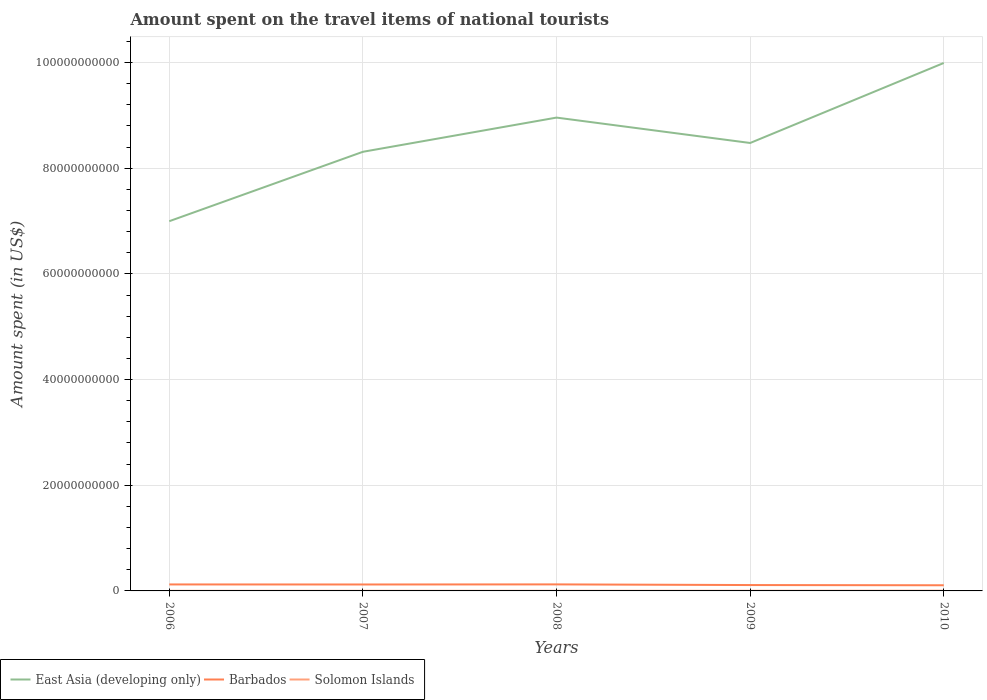Does the line corresponding to Solomon Islands intersect with the line corresponding to Barbados?
Offer a very short reply. No. Is the number of lines equal to the number of legend labels?
Provide a short and direct response. Yes. Across all years, what is the maximum amount spent on the travel items of national tourists in East Asia (developing only)?
Make the answer very short. 7.00e+1. What is the total amount spent on the travel items of national tourists in East Asia (developing only) in the graph?
Provide a succinct answer. -2.99e+1. What is the difference between the highest and the second highest amount spent on the travel items of national tourists in East Asia (developing only)?
Offer a very short reply. 2.99e+1. What is the difference between the highest and the lowest amount spent on the travel items of national tourists in Solomon Islands?
Ensure brevity in your answer.  2. Are the values on the major ticks of Y-axis written in scientific E-notation?
Provide a succinct answer. No. Does the graph contain grids?
Ensure brevity in your answer.  Yes. What is the title of the graph?
Your answer should be compact. Amount spent on the travel items of national tourists. Does "Dominica" appear as one of the legend labels in the graph?
Your response must be concise. No. What is the label or title of the X-axis?
Provide a short and direct response. Years. What is the label or title of the Y-axis?
Your answer should be compact. Amount spent (in US$). What is the Amount spent (in US$) in East Asia (developing only) in 2006?
Ensure brevity in your answer.  7.00e+1. What is the Amount spent (in US$) of Barbados in 2006?
Your response must be concise. 1.23e+09. What is the Amount spent (in US$) in Solomon Islands in 2006?
Give a very brief answer. 2.11e+07. What is the Amount spent (in US$) of East Asia (developing only) in 2007?
Give a very brief answer. 8.31e+1. What is the Amount spent (in US$) of Barbados in 2007?
Make the answer very short. 1.22e+09. What is the Amount spent (in US$) of Solomon Islands in 2007?
Make the answer very short. 2.26e+07. What is the Amount spent (in US$) in East Asia (developing only) in 2008?
Give a very brief answer. 8.96e+1. What is the Amount spent (in US$) in Barbados in 2008?
Offer a terse response. 1.24e+09. What is the Amount spent (in US$) of Solomon Islands in 2008?
Give a very brief answer. 2.75e+07. What is the Amount spent (in US$) of East Asia (developing only) in 2009?
Offer a very short reply. 8.48e+1. What is the Amount spent (in US$) of Barbados in 2009?
Provide a succinct answer. 1.11e+09. What is the Amount spent (in US$) of Solomon Islands in 2009?
Keep it short and to the point. 3.34e+07. What is the Amount spent (in US$) in East Asia (developing only) in 2010?
Offer a very short reply. 9.99e+1. What is the Amount spent (in US$) of Barbados in 2010?
Give a very brief answer. 1.07e+09. What is the Amount spent (in US$) in Solomon Islands in 2010?
Provide a short and direct response. 4.35e+07. Across all years, what is the maximum Amount spent (in US$) of East Asia (developing only)?
Your response must be concise. 9.99e+1. Across all years, what is the maximum Amount spent (in US$) of Barbados?
Ensure brevity in your answer.  1.24e+09. Across all years, what is the maximum Amount spent (in US$) of Solomon Islands?
Offer a very short reply. 4.35e+07. Across all years, what is the minimum Amount spent (in US$) of East Asia (developing only)?
Offer a very short reply. 7.00e+1. Across all years, what is the minimum Amount spent (in US$) in Barbados?
Your answer should be compact. 1.07e+09. Across all years, what is the minimum Amount spent (in US$) in Solomon Islands?
Your answer should be very brief. 2.11e+07. What is the total Amount spent (in US$) of East Asia (developing only) in the graph?
Keep it short and to the point. 4.27e+11. What is the total Amount spent (in US$) in Barbados in the graph?
Keep it short and to the point. 5.86e+09. What is the total Amount spent (in US$) of Solomon Islands in the graph?
Keep it short and to the point. 1.48e+08. What is the difference between the Amount spent (in US$) in East Asia (developing only) in 2006 and that in 2007?
Offer a terse response. -1.31e+1. What is the difference between the Amount spent (in US$) of Barbados in 2006 and that in 2007?
Your response must be concise. 1.10e+07. What is the difference between the Amount spent (in US$) of Solomon Islands in 2006 and that in 2007?
Offer a terse response. -1.50e+06. What is the difference between the Amount spent (in US$) of East Asia (developing only) in 2006 and that in 2008?
Give a very brief answer. -1.96e+1. What is the difference between the Amount spent (in US$) in Barbados in 2006 and that in 2008?
Ensure brevity in your answer.  -9.00e+06. What is the difference between the Amount spent (in US$) of Solomon Islands in 2006 and that in 2008?
Keep it short and to the point. -6.40e+06. What is the difference between the Amount spent (in US$) in East Asia (developing only) in 2006 and that in 2009?
Offer a very short reply. -1.48e+1. What is the difference between the Amount spent (in US$) in Barbados in 2006 and that in 2009?
Provide a short and direct response. 1.16e+08. What is the difference between the Amount spent (in US$) in Solomon Islands in 2006 and that in 2009?
Provide a succinct answer. -1.23e+07. What is the difference between the Amount spent (in US$) in East Asia (developing only) in 2006 and that in 2010?
Provide a short and direct response. -2.99e+1. What is the difference between the Amount spent (in US$) of Barbados in 2006 and that in 2010?
Offer a very short reply. 1.57e+08. What is the difference between the Amount spent (in US$) in Solomon Islands in 2006 and that in 2010?
Keep it short and to the point. -2.24e+07. What is the difference between the Amount spent (in US$) of East Asia (developing only) in 2007 and that in 2008?
Keep it short and to the point. -6.47e+09. What is the difference between the Amount spent (in US$) of Barbados in 2007 and that in 2008?
Give a very brief answer. -2.00e+07. What is the difference between the Amount spent (in US$) of Solomon Islands in 2007 and that in 2008?
Provide a succinct answer. -4.90e+06. What is the difference between the Amount spent (in US$) in East Asia (developing only) in 2007 and that in 2009?
Make the answer very short. -1.67e+09. What is the difference between the Amount spent (in US$) of Barbados in 2007 and that in 2009?
Your response must be concise. 1.05e+08. What is the difference between the Amount spent (in US$) of Solomon Islands in 2007 and that in 2009?
Make the answer very short. -1.08e+07. What is the difference between the Amount spent (in US$) in East Asia (developing only) in 2007 and that in 2010?
Provide a short and direct response. -1.68e+1. What is the difference between the Amount spent (in US$) in Barbados in 2007 and that in 2010?
Make the answer very short. 1.46e+08. What is the difference between the Amount spent (in US$) of Solomon Islands in 2007 and that in 2010?
Your answer should be very brief. -2.09e+07. What is the difference between the Amount spent (in US$) in East Asia (developing only) in 2008 and that in 2009?
Offer a very short reply. 4.81e+09. What is the difference between the Amount spent (in US$) in Barbados in 2008 and that in 2009?
Offer a terse response. 1.25e+08. What is the difference between the Amount spent (in US$) of Solomon Islands in 2008 and that in 2009?
Offer a terse response. -5.90e+06. What is the difference between the Amount spent (in US$) of East Asia (developing only) in 2008 and that in 2010?
Provide a short and direct response. -1.03e+1. What is the difference between the Amount spent (in US$) in Barbados in 2008 and that in 2010?
Your response must be concise. 1.66e+08. What is the difference between the Amount spent (in US$) in Solomon Islands in 2008 and that in 2010?
Your answer should be compact. -1.60e+07. What is the difference between the Amount spent (in US$) in East Asia (developing only) in 2009 and that in 2010?
Ensure brevity in your answer.  -1.51e+1. What is the difference between the Amount spent (in US$) of Barbados in 2009 and that in 2010?
Offer a very short reply. 4.10e+07. What is the difference between the Amount spent (in US$) in Solomon Islands in 2009 and that in 2010?
Give a very brief answer. -1.01e+07. What is the difference between the Amount spent (in US$) in East Asia (developing only) in 2006 and the Amount spent (in US$) in Barbados in 2007?
Keep it short and to the point. 6.88e+1. What is the difference between the Amount spent (in US$) of East Asia (developing only) in 2006 and the Amount spent (in US$) of Solomon Islands in 2007?
Offer a very short reply. 7.00e+1. What is the difference between the Amount spent (in US$) of Barbados in 2006 and the Amount spent (in US$) of Solomon Islands in 2007?
Your answer should be compact. 1.21e+09. What is the difference between the Amount spent (in US$) of East Asia (developing only) in 2006 and the Amount spent (in US$) of Barbados in 2008?
Provide a short and direct response. 6.87e+1. What is the difference between the Amount spent (in US$) in East Asia (developing only) in 2006 and the Amount spent (in US$) in Solomon Islands in 2008?
Your response must be concise. 6.99e+1. What is the difference between the Amount spent (in US$) in Barbados in 2006 and the Amount spent (in US$) in Solomon Islands in 2008?
Keep it short and to the point. 1.20e+09. What is the difference between the Amount spent (in US$) of East Asia (developing only) in 2006 and the Amount spent (in US$) of Barbados in 2009?
Offer a terse response. 6.89e+1. What is the difference between the Amount spent (in US$) of East Asia (developing only) in 2006 and the Amount spent (in US$) of Solomon Islands in 2009?
Provide a succinct answer. 6.99e+1. What is the difference between the Amount spent (in US$) of Barbados in 2006 and the Amount spent (in US$) of Solomon Islands in 2009?
Provide a short and direct response. 1.19e+09. What is the difference between the Amount spent (in US$) in East Asia (developing only) in 2006 and the Amount spent (in US$) in Barbados in 2010?
Your answer should be very brief. 6.89e+1. What is the difference between the Amount spent (in US$) of East Asia (developing only) in 2006 and the Amount spent (in US$) of Solomon Islands in 2010?
Offer a terse response. 6.99e+1. What is the difference between the Amount spent (in US$) of Barbados in 2006 and the Amount spent (in US$) of Solomon Islands in 2010?
Provide a short and direct response. 1.18e+09. What is the difference between the Amount spent (in US$) of East Asia (developing only) in 2007 and the Amount spent (in US$) of Barbados in 2008?
Make the answer very short. 8.19e+1. What is the difference between the Amount spent (in US$) in East Asia (developing only) in 2007 and the Amount spent (in US$) in Solomon Islands in 2008?
Make the answer very short. 8.31e+1. What is the difference between the Amount spent (in US$) of Barbados in 2007 and the Amount spent (in US$) of Solomon Islands in 2008?
Give a very brief answer. 1.19e+09. What is the difference between the Amount spent (in US$) of East Asia (developing only) in 2007 and the Amount spent (in US$) of Barbados in 2009?
Offer a terse response. 8.20e+1. What is the difference between the Amount spent (in US$) of East Asia (developing only) in 2007 and the Amount spent (in US$) of Solomon Islands in 2009?
Offer a terse response. 8.31e+1. What is the difference between the Amount spent (in US$) in Barbados in 2007 and the Amount spent (in US$) in Solomon Islands in 2009?
Offer a very short reply. 1.18e+09. What is the difference between the Amount spent (in US$) of East Asia (developing only) in 2007 and the Amount spent (in US$) of Barbados in 2010?
Ensure brevity in your answer.  8.20e+1. What is the difference between the Amount spent (in US$) of East Asia (developing only) in 2007 and the Amount spent (in US$) of Solomon Islands in 2010?
Your response must be concise. 8.31e+1. What is the difference between the Amount spent (in US$) of Barbados in 2007 and the Amount spent (in US$) of Solomon Islands in 2010?
Provide a succinct answer. 1.17e+09. What is the difference between the Amount spent (in US$) of East Asia (developing only) in 2008 and the Amount spent (in US$) of Barbados in 2009?
Give a very brief answer. 8.85e+1. What is the difference between the Amount spent (in US$) of East Asia (developing only) in 2008 and the Amount spent (in US$) of Solomon Islands in 2009?
Keep it short and to the point. 8.96e+1. What is the difference between the Amount spent (in US$) in Barbados in 2008 and the Amount spent (in US$) in Solomon Islands in 2009?
Your answer should be very brief. 1.20e+09. What is the difference between the Amount spent (in US$) of East Asia (developing only) in 2008 and the Amount spent (in US$) of Barbados in 2010?
Ensure brevity in your answer.  8.85e+1. What is the difference between the Amount spent (in US$) in East Asia (developing only) in 2008 and the Amount spent (in US$) in Solomon Islands in 2010?
Your answer should be compact. 8.95e+1. What is the difference between the Amount spent (in US$) of Barbados in 2008 and the Amount spent (in US$) of Solomon Islands in 2010?
Your answer should be very brief. 1.19e+09. What is the difference between the Amount spent (in US$) in East Asia (developing only) in 2009 and the Amount spent (in US$) in Barbados in 2010?
Make the answer very short. 8.37e+1. What is the difference between the Amount spent (in US$) in East Asia (developing only) in 2009 and the Amount spent (in US$) in Solomon Islands in 2010?
Your response must be concise. 8.47e+1. What is the difference between the Amount spent (in US$) in Barbados in 2009 and the Amount spent (in US$) in Solomon Islands in 2010?
Your answer should be very brief. 1.07e+09. What is the average Amount spent (in US$) in East Asia (developing only) per year?
Your answer should be compact. 8.55e+1. What is the average Amount spent (in US$) in Barbados per year?
Make the answer very short. 1.17e+09. What is the average Amount spent (in US$) in Solomon Islands per year?
Offer a very short reply. 2.96e+07. In the year 2006, what is the difference between the Amount spent (in US$) of East Asia (developing only) and Amount spent (in US$) of Barbados?
Ensure brevity in your answer.  6.87e+1. In the year 2006, what is the difference between the Amount spent (in US$) in East Asia (developing only) and Amount spent (in US$) in Solomon Islands?
Offer a very short reply. 7.00e+1. In the year 2006, what is the difference between the Amount spent (in US$) of Barbados and Amount spent (in US$) of Solomon Islands?
Offer a terse response. 1.21e+09. In the year 2007, what is the difference between the Amount spent (in US$) of East Asia (developing only) and Amount spent (in US$) of Barbados?
Give a very brief answer. 8.19e+1. In the year 2007, what is the difference between the Amount spent (in US$) of East Asia (developing only) and Amount spent (in US$) of Solomon Islands?
Give a very brief answer. 8.31e+1. In the year 2007, what is the difference between the Amount spent (in US$) of Barbados and Amount spent (in US$) of Solomon Islands?
Ensure brevity in your answer.  1.19e+09. In the year 2008, what is the difference between the Amount spent (in US$) of East Asia (developing only) and Amount spent (in US$) of Barbados?
Make the answer very short. 8.83e+1. In the year 2008, what is the difference between the Amount spent (in US$) of East Asia (developing only) and Amount spent (in US$) of Solomon Islands?
Keep it short and to the point. 8.96e+1. In the year 2008, what is the difference between the Amount spent (in US$) of Barbados and Amount spent (in US$) of Solomon Islands?
Give a very brief answer. 1.21e+09. In the year 2009, what is the difference between the Amount spent (in US$) of East Asia (developing only) and Amount spent (in US$) of Barbados?
Your answer should be very brief. 8.37e+1. In the year 2009, what is the difference between the Amount spent (in US$) in East Asia (developing only) and Amount spent (in US$) in Solomon Islands?
Ensure brevity in your answer.  8.47e+1. In the year 2009, what is the difference between the Amount spent (in US$) of Barbados and Amount spent (in US$) of Solomon Islands?
Offer a very short reply. 1.08e+09. In the year 2010, what is the difference between the Amount spent (in US$) of East Asia (developing only) and Amount spent (in US$) of Barbados?
Provide a short and direct response. 9.89e+1. In the year 2010, what is the difference between the Amount spent (in US$) of East Asia (developing only) and Amount spent (in US$) of Solomon Islands?
Make the answer very short. 9.99e+1. In the year 2010, what is the difference between the Amount spent (in US$) of Barbados and Amount spent (in US$) of Solomon Islands?
Your answer should be very brief. 1.03e+09. What is the ratio of the Amount spent (in US$) in East Asia (developing only) in 2006 to that in 2007?
Provide a short and direct response. 0.84. What is the ratio of the Amount spent (in US$) in Barbados in 2006 to that in 2007?
Give a very brief answer. 1.01. What is the ratio of the Amount spent (in US$) of Solomon Islands in 2006 to that in 2007?
Your response must be concise. 0.93. What is the ratio of the Amount spent (in US$) in East Asia (developing only) in 2006 to that in 2008?
Offer a very short reply. 0.78. What is the ratio of the Amount spent (in US$) in Solomon Islands in 2006 to that in 2008?
Make the answer very short. 0.77. What is the ratio of the Amount spent (in US$) in East Asia (developing only) in 2006 to that in 2009?
Your answer should be compact. 0.83. What is the ratio of the Amount spent (in US$) in Barbados in 2006 to that in 2009?
Provide a short and direct response. 1.1. What is the ratio of the Amount spent (in US$) of Solomon Islands in 2006 to that in 2009?
Your response must be concise. 0.63. What is the ratio of the Amount spent (in US$) in East Asia (developing only) in 2006 to that in 2010?
Provide a succinct answer. 0.7. What is the ratio of the Amount spent (in US$) of Barbados in 2006 to that in 2010?
Offer a very short reply. 1.15. What is the ratio of the Amount spent (in US$) of Solomon Islands in 2006 to that in 2010?
Offer a terse response. 0.49. What is the ratio of the Amount spent (in US$) in East Asia (developing only) in 2007 to that in 2008?
Your response must be concise. 0.93. What is the ratio of the Amount spent (in US$) of Barbados in 2007 to that in 2008?
Make the answer very short. 0.98. What is the ratio of the Amount spent (in US$) of Solomon Islands in 2007 to that in 2008?
Keep it short and to the point. 0.82. What is the ratio of the Amount spent (in US$) of East Asia (developing only) in 2007 to that in 2009?
Offer a very short reply. 0.98. What is the ratio of the Amount spent (in US$) of Barbados in 2007 to that in 2009?
Give a very brief answer. 1.09. What is the ratio of the Amount spent (in US$) in Solomon Islands in 2007 to that in 2009?
Ensure brevity in your answer.  0.68. What is the ratio of the Amount spent (in US$) in East Asia (developing only) in 2007 to that in 2010?
Ensure brevity in your answer.  0.83. What is the ratio of the Amount spent (in US$) in Barbados in 2007 to that in 2010?
Keep it short and to the point. 1.14. What is the ratio of the Amount spent (in US$) of Solomon Islands in 2007 to that in 2010?
Ensure brevity in your answer.  0.52. What is the ratio of the Amount spent (in US$) in East Asia (developing only) in 2008 to that in 2009?
Your answer should be very brief. 1.06. What is the ratio of the Amount spent (in US$) of Barbados in 2008 to that in 2009?
Offer a very short reply. 1.11. What is the ratio of the Amount spent (in US$) in Solomon Islands in 2008 to that in 2009?
Give a very brief answer. 0.82. What is the ratio of the Amount spent (in US$) of East Asia (developing only) in 2008 to that in 2010?
Provide a short and direct response. 0.9. What is the ratio of the Amount spent (in US$) of Barbados in 2008 to that in 2010?
Make the answer very short. 1.16. What is the ratio of the Amount spent (in US$) of Solomon Islands in 2008 to that in 2010?
Provide a succinct answer. 0.63. What is the ratio of the Amount spent (in US$) in East Asia (developing only) in 2009 to that in 2010?
Make the answer very short. 0.85. What is the ratio of the Amount spent (in US$) of Barbados in 2009 to that in 2010?
Make the answer very short. 1.04. What is the ratio of the Amount spent (in US$) of Solomon Islands in 2009 to that in 2010?
Offer a very short reply. 0.77. What is the difference between the highest and the second highest Amount spent (in US$) of East Asia (developing only)?
Give a very brief answer. 1.03e+1. What is the difference between the highest and the second highest Amount spent (in US$) in Barbados?
Offer a terse response. 9.00e+06. What is the difference between the highest and the second highest Amount spent (in US$) of Solomon Islands?
Keep it short and to the point. 1.01e+07. What is the difference between the highest and the lowest Amount spent (in US$) in East Asia (developing only)?
Offer a terse response. 2.99e+1. What is the difference between the highest and the lowest Amount spent (in US$) in Barbados?
Give a very brief answer. 1.66e+08. What is the difference between the highest and the lowest Amount spent (in US$) of Solomon Islands?
Offer a terse response. 2.24e+07. 